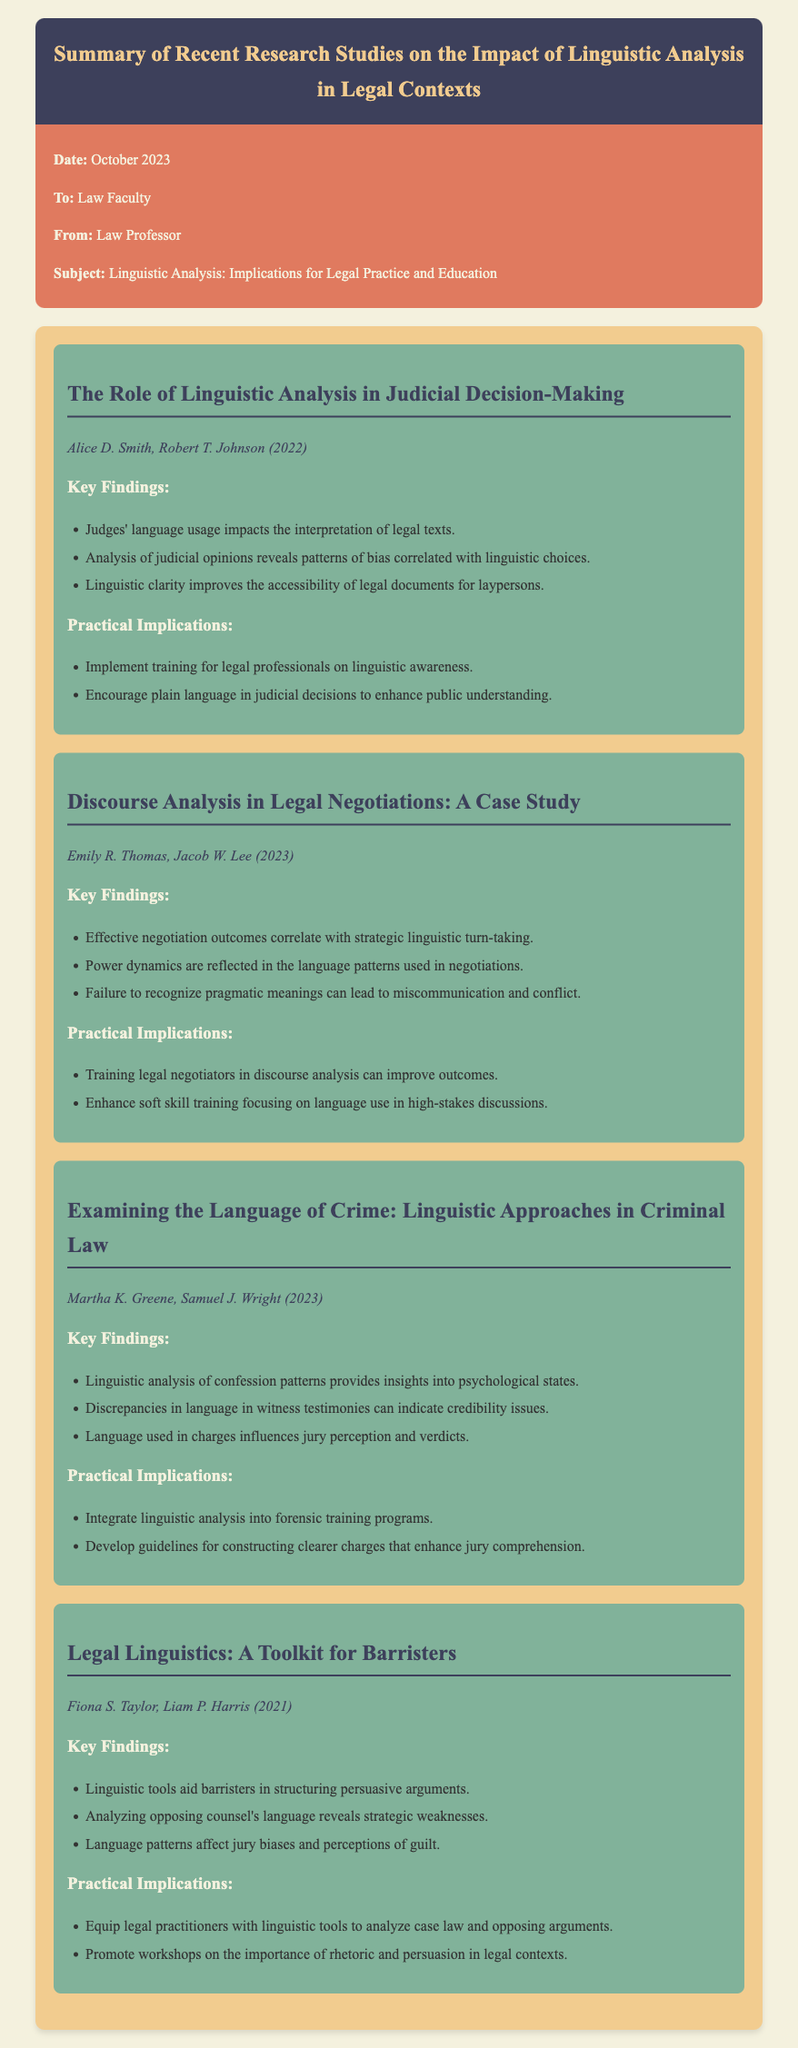What is the title of the memo? The title of the memo is located at the top and summarizes the focus of the research studies.
Answer: Summary of Recent Research Studies on the Impact of Linguistic Analysis in Legal Contexts Who are the authors of the study on judicial decision-making? The authors' names for the specific study can be found under each study's title.
Answer: Alice D. Smith, Robert T. Johnson What year was the study on discourse analysis published? The publication year is indicated next to the authors' names in the section for that study.
Answer: 2023 What is one key finding from the criminal law study? Each study lists key findings in bullet points, which provide insights from the research.
Answer: Linguistic analysis of confession patterns provides insights into psychological states What practical implication is suggested for barristers based on their toolkit study? The practical implications for each study highlight recommendations for legal practitioners.
Answer: Equip legal practitioners with linguistic tools to analyze case law and opposing arguments How many studies are summarized in the memo? Counting the number of individual studies presented in the memo gives the total.
Answer: Four What is the publication date of the memo? The publication date is listed in the memo details at the beginning of the document.
Answer: October 2023 Who are the authors of the final study on legal linguistics? The authors' names for the specific study can be found under each study's title.
Answer: Fiona S. Taylor, Liam P. Harris What color is used for the memo's header background? The color used in the header is indicated by the style applied to that section of the document.
Answer: Dark blue 